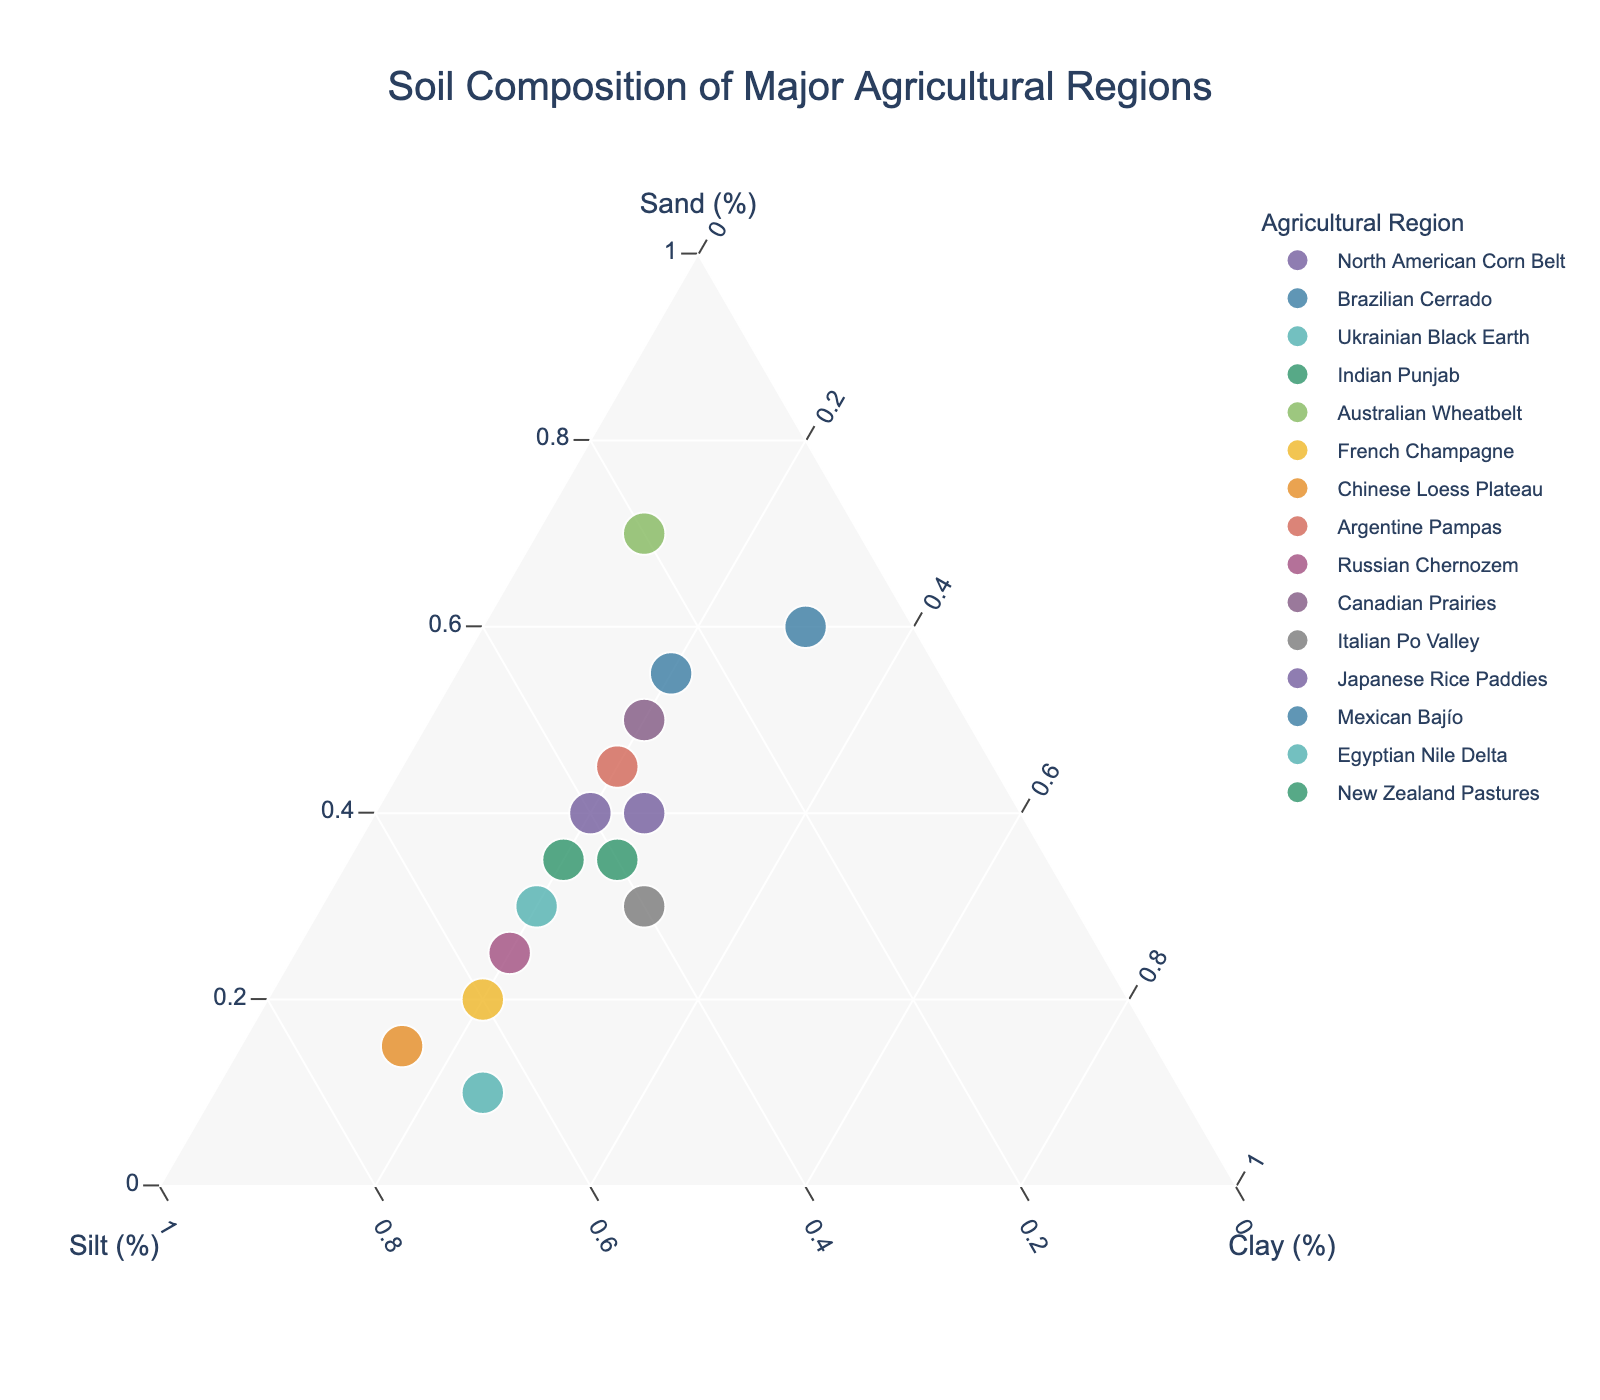Which region has the highest percentage of Sand? The data points near the "Sand" axis will have higher sand content. The Australian Wheatbelt is closest to the Sand axis with 70%.
Answer: Australian Wheatbelt Which region has the highest percentage of Silt? The data points near the "Silt" axis will have higher silt content. The Chinese Loess Plateau is closest to the Silt axis with 70%.
Answer: Chinese Loess Plateau What's the average percentage of Clay for the Italian Po Valley and Brazilian Cerrado regions? The Italian Po Valley and Brazilian Cerrado have 30% and 30% of Clay respectively. The average is (30 + 30) / 2.
Answer: 30% Which region has equal percentages of Sand and Silt? A region with equal Sand and Silt percentages will lie on the bisector of the Sand and Silt axes. The North American Corn Belt has 40% Sand and 40% Silt.
Answer: North American Corn Belt Which region has the lowest Sand content? The data points near the "Clay" and "Silt" axes will have lower sand content. The Egyptian Nile Delta has the lowest with 10%.
Answer: Egyptian Nile Delta Compare the Sand content between Japanese Rice Paddies and Canadian Prairies. Which has more? Japanese Rice Paddies have 40% Sand, while the Canadian Prairies have 50% Sand.
Answer: Canadian Prairies Are there any regions with 20% Clay content? If so, name them. Find points where the Clay percentage is marked at 20%. These regions are North American Corn Belt, Ukrainian Black Earth, Indian Punjab, Argentine Pampas, Russian Chernozem, Mexican Bajío.
Answer: North American Corn Belt, Ukrainian Black Earth, Indian Punjab, Argentine Pampas, Russian Chernozem, Mexican Bajío What’s the difference in Silt content between the French Champagne and the Mexican Bajío? French Champagne has 60% Silt and Mexican Bajío has 25% Silt. The difference is 60 - 25.
Answer: 35% Which region has nearly equal proportions of Sand, Silt, and Clay? Find the data points near the center of the plot, indicating roughly equal proportions of each element. Japanese Rice Paddies with 40% Sand, 35% Silt, and 25% Clay is closest to this.
Answer: Japanese Rice Paddies Does any region have more Clay than Sand? Check for regions where the Clay percentage exceeds the Sand percentage. Italian Po Valley has 30% Clay and 30% Sand, however, none with more Clay than Sand.
Answer: No 